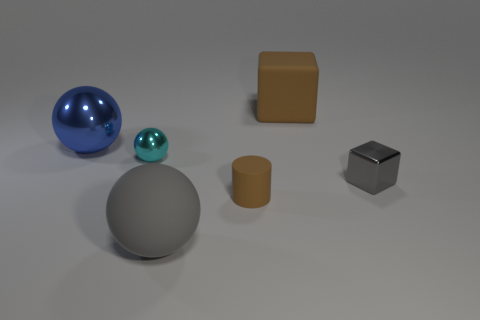Add 3 small purple shiny objects. How many objects exist? 9 Subtract all cubes. How many objects are left? 4 Subtract all brown metallic cylinders. Subtract all cyan metal objects. How many objects are left? 5 Add 2 big brown things. How many big brown things are left? 3 Add 3 big shiny spheres. How many big shiny spheres exist? 4 Subtract 0 yellow cubes. How many objects are left? 6 